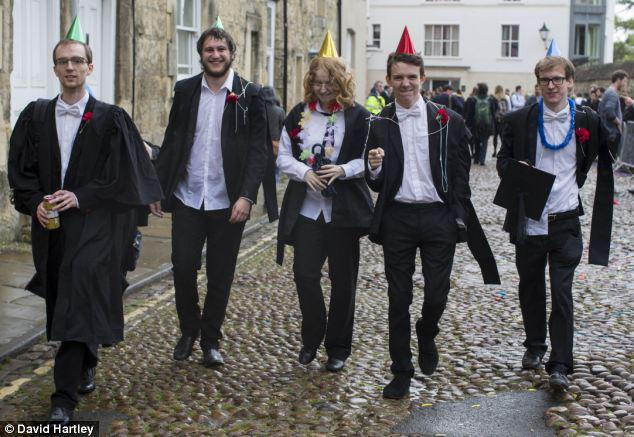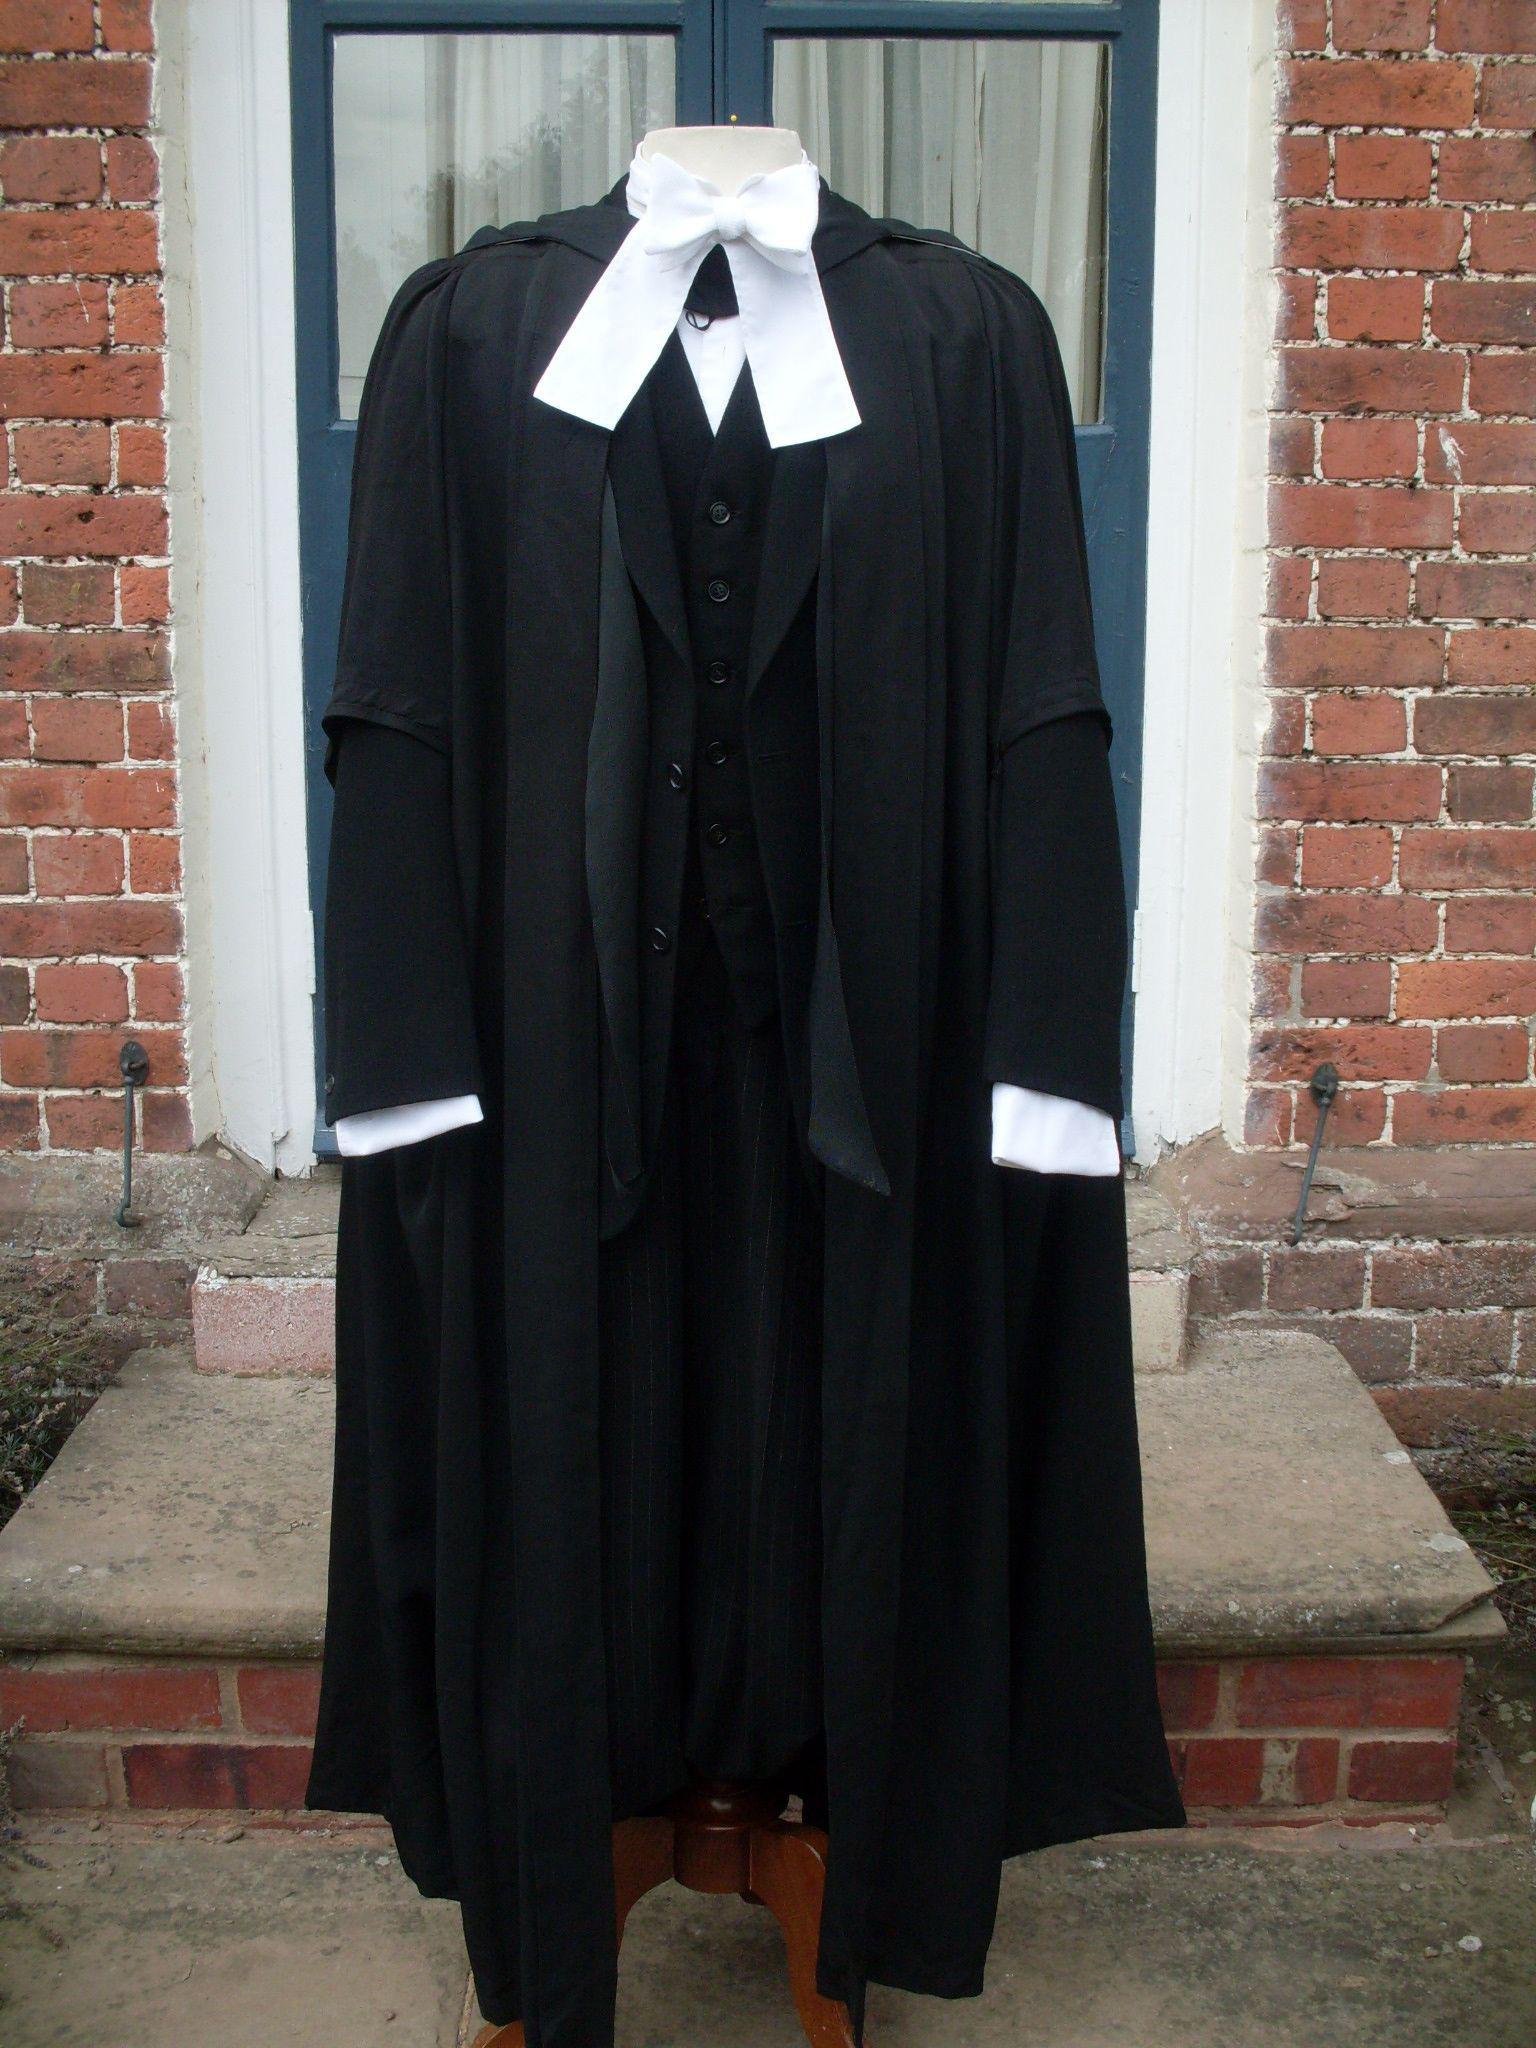The first image is the image on the left, the second image is the image on the right. Considering the images on both sides, is "An image shows exactly one black gradulation robe with white embellishments, displayed on a headless form." valid? Answer yes or no. Yes. The first image is the image on the left, the second image is the image on the right. Evaluate the accuracy of this statement regarding the images: "There are exactly three graduation robes, two in one image and one in the other, one or more robes does not contain people.". Is it true? Answer yes or no. No. 